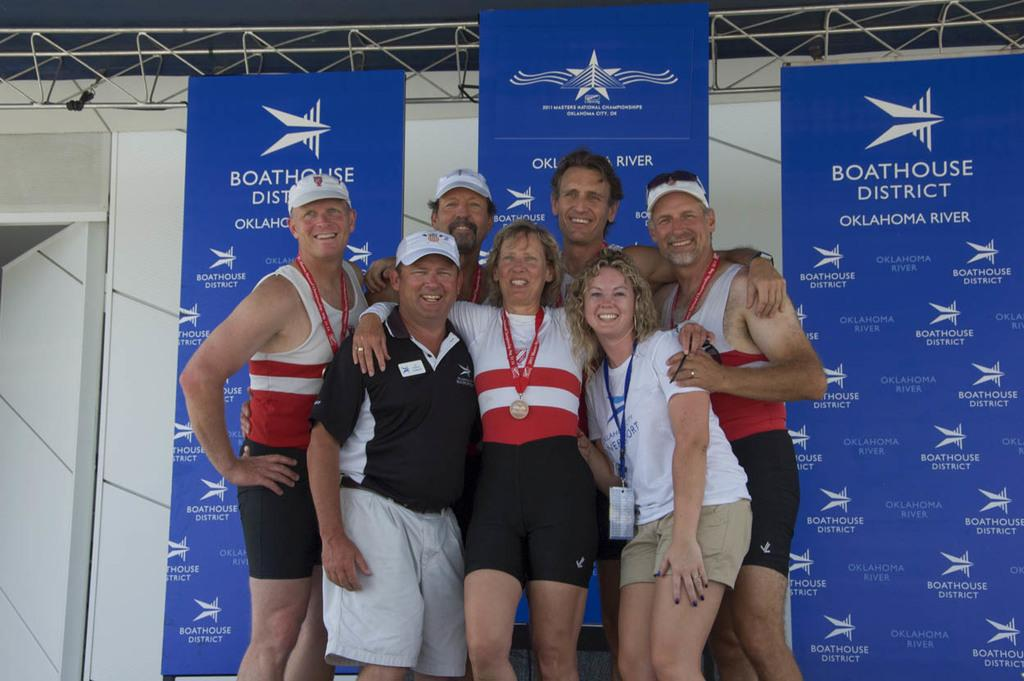<image>
Relay a brief, clear account of the picture shown. several people posing for a photograph in front of three boathouse district banners. 